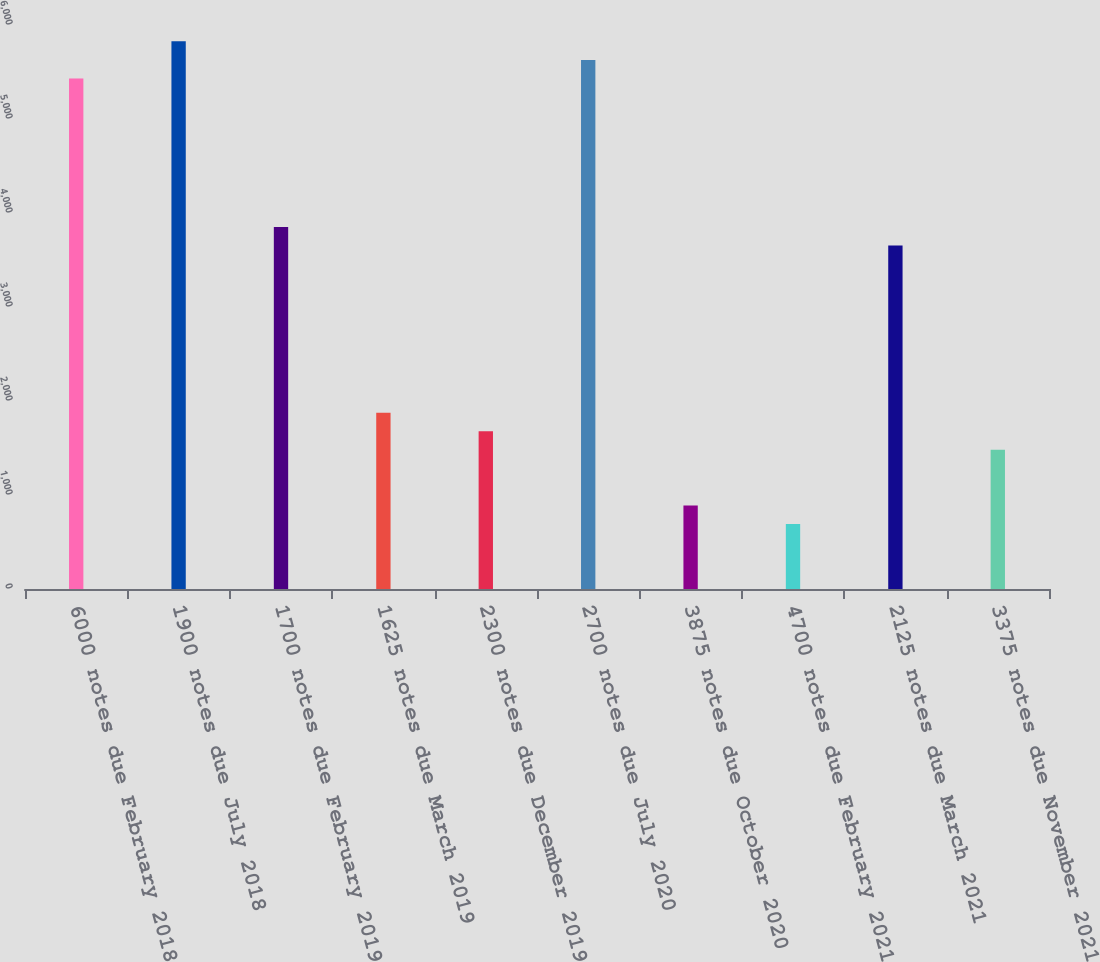Convert chart to OTSL. <chart><loc_0><loc_0><loc_500><loc_500><bar_chart><fcel>6000 notes due February 2018<fcel>1900 notes due July 2018<fcel>1700 notes due February 2019<fcel>1625 notes due March 2019<fcel>2300 notes due December 2019<fcel>2700 notes due July 2020<fcel>3875 notes due October 2020<fcel>4700 notes due February 2021<fcel>2125 notes due March 2021<fcel>3375 notes due November 2021<nl><fcel>5431<fcel>5826<fcel>3851<fcel>1876<fcel>1678.5<fcel>5628.5<fcel>888.5<fcel>691<fcel>3653.5<fcel>1481<nl></chart> 